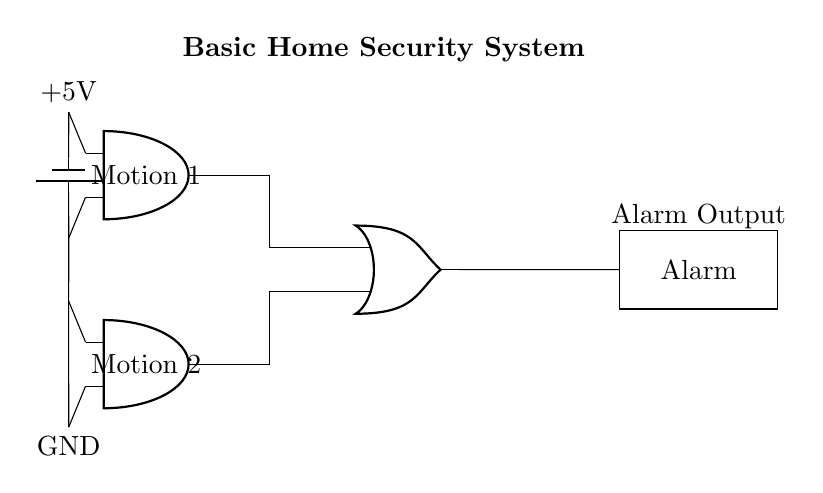What components are in this circuit? The circuit contains two motion sensors, an OR gate, and an alarm output, indicating the main components involved in detecting motion and triggering the alarm.
Answer: motion sensors, OR gate, alarm output What is the voltage of the power supply? The voltage of the power supply is indicated as +5V, which is the source providing power to the circuit components.
Answer: 5V How many motion sensors are present in this circuit? There are two motion sensors depicted in the circuit, which would be used to detect movement in different areas of a home.
Answer: 2 What does the OR gate do in this circuit? The OR gate combines the outputs from the two motion sensors, meaning that if either sensor detects motion, the alarm will be triggered.
Answer: combines signals What is the purpose of the alarm output? The alarm output is designed to trigger a sound or alert when motion is detected by either of the sensors, thus providing security by notifying of potential intrusions.
Answer: triggers alarm When will the alarm be activated in this circuit? The alarm will be activated when either of the motion sensors sends a signal to the OR gate, indicating detection of motion, resulting in a signal sent to the alarm.
Answer: when motion is detected 